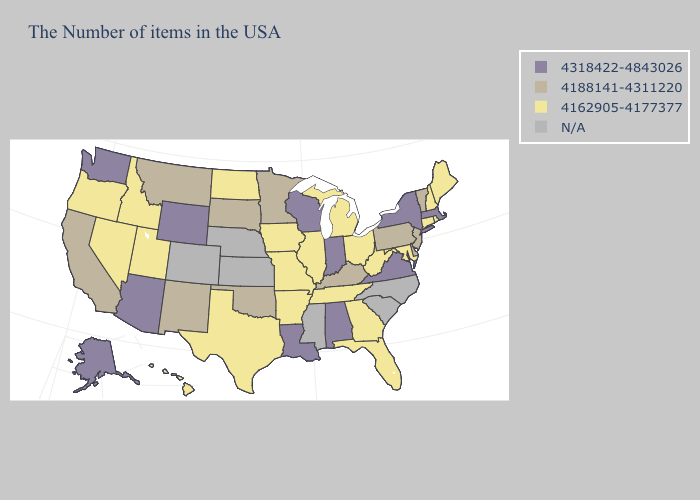What is the lowest value in the South?
Answer briefly. 4162905-4177377. Name the states that have a value in the range N/A?
Quick response, please. North Carolina, South Carolina, Mississippi, Kansas, Nebraska, Colorado. Name the states that have a value in the range 4318422-4843026?
Give a very brief answer. Massachusetts, New York, Virginia, Indiana, Alabama, Wisconsin, Louisiana, Wyoming, Arizona, Washington, Alaska. What is the highest value in the USA?
Concise answer only. 4318422-4843026. What is the highest value in the USA?
Write a very short answer. 4318422-4843026. Name the states that have a value in the range N/A?
Be succinct. North Carolina, South Carolina, Mississippi, Kansas, Nebraska, Colorado. Name the states that have a value in the range N/A?
Write a very short answer. North Carolina, South Carolina, Mississippi, Kansas, Nebraska, Colorado. Name the states that have a value in the range 4318422-4843026?
Short answer required. Massachusetts, New York, Virginia, Indiana, Alabama, Wisconsin, Louisiana, Wyoming, Arizona, Washington, Alaska. What is the value of North Carolina?
Give a very brief answer. N/A. Name the states that have a value in the range 4318422-4843026?
Quick response, please. Massachusetts, New York, Virginia, Indiana, Alabama, Wisconsin, Louisiana, Wyoming, Arizona, Washington, Alaska. Name the states that have a value in the range 4162905-4177377?
Answer briefly. Maine, Rhode Island, New Hampshire, Connecticut, Maryland, West Virginia, Ohio, Florida, Georgia, Michigan, Tennessee, Illinois, Missouri, Arkansas, Iowa, Texas, North Dakota, Utah, Idaho, Nevada, Oregon, Hawaii. Among the states that border Illinois , does Indiana have the highest value?
Quick response, please. Yes. Which states have the highest value in the USA?
Be succinct. Massachusetts, New York, Virginia, Indiana, Alabama, Wisconsin, Louisiana, Wyoming, Arizona, Washington, Alaska. What is the value of Arkansas?
Give a very brief answer. 4162905-4177377. How many symbols are there in the legend?
Short answer required. 4. 